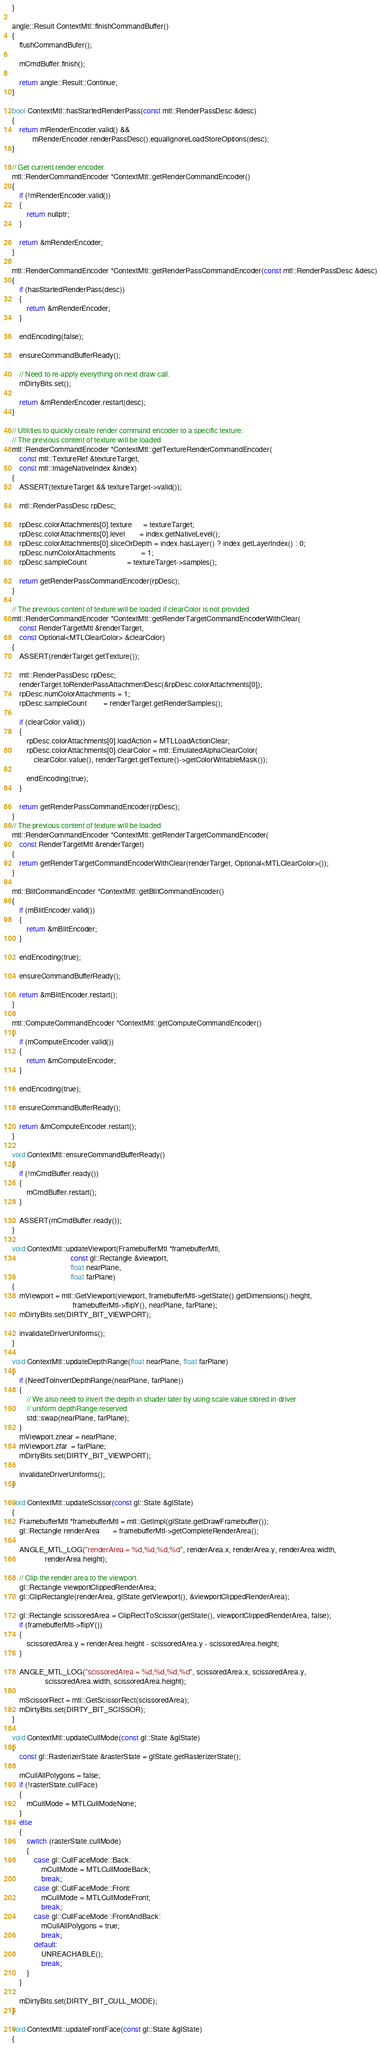<code> <loc_0><loc_0><loc_500><loc_500><_ObjectiveC_>}

angle::Result ContextMtl::finishCommandBuffer()
{
    flushCommandBufer();

    mCmdBuffer.finish();

    return angle::Result::Continue;
}

bool ContextMtl::hasStartedRenderPass(const mtl::RenderPassDesc &desc)
{
    return mRenderEncoder.valid() &&
           mRenderEncoder.renderPassDesc().equalIgnoreLoadStoreOptions(desc);
}

// Get current render encoder
mtl::RenderCommandEncoder *ContextMtl::getRenderCommandEncoder()
{
    if (!mRenderEncoder.valid())
    {
        return nullptr;
    }

    return &mRenderEncoder;
}

mtl::RenderCommandEncoder *ContextMtl::getRenderPassCommandEncoder(const mtl::RenderPassDesc &desc)
{
    if (hasStartedRenderPass(desc))
    {
        return &mRenderEncoder;
    }

    endEncoding(false);

    ensureCommandBufferReady();

    // Need to re-apply everything on next draw call.
    mDirtyBits.set();

    return &mRenderEncoder.restart(desc);
}

// Utilities to quickly create render command encoder to a specific texture:
// The previous content of texture will be loaded
mtl::RenderCommandEncoder *ContextMtl::getTextureRenderCommandEncoder(
    const mtl::TextureRef &textureTarget,
    const mtl::ImageNativeIndex &index)
{
    ASSERT(textureTarget && textureTarget->valid());

    mtl::RenderPassDesc rpDesc;

    rpDesc.colorAttachments[0].texture      = textureTarget;
    rpDesc.colorAttachments[0].level        = index.getNativeLevel();
    rpDesc.colorAttachments[0].sliceOrDepth = index.hasLayer() ? index.getLayerIndex() : 0;
    rpDesc.numColorAttachments              = 1;
    rpDesc.sampleCount                      = textureTarget->samples();

    return getRenderPassCommandEncoder(rpDesc);
}

// The previous content of texture will be loaded if clearColor is not provided
mtl::RenderCommandEncoder *ContextMtl::getRenderTargetCommandEncoderWithClear(
    const RenderTargetMtl &renderTarget,
    const Optional<MTLClearColor> &clearColor)
{
    ASSERT(renderTarget.getTexture());

    mtl::RenderPassDesc rpDesc;
    renderTarget.toRenderPassAttachmentDesc(&rpDesc.colorAttachments[0]);
    rpDesc.numColorAttachments = 1;
    rpDesc.sampleCount         = renderTarget.getRenderSamples();

    if (clearColor.valid())
    {
        rpDesc.colorAttachments[0].loadAction = MTLLoadActionClear;
        rpDesc.colorAttachments[0].clearColor = mtl::EmulatedAlphaClearColor(
            clearColor.value(), renderTarget.getTexture()->getColorWritableMask());

        endEncoding(true);
    }

    return getRenderPassCommandEncoder(rpDesc);
}
// The previous content of texture will be loaded
mtl::RenderCommandEncoder *ContextMtl::getRenderTargetCommandEncoder(
    const RenderTargetMtl &renderTarget)
{
    return getRenderTargetCommandEncoderWithClear(renderTarget, Optional<MTLClearColor>());
}

mtl::BlitCommandEncoder *ContextMtl::getBlitCommandEncoder()
{
    if (mBlitEncoder.valid())
    {
        return &mBlitEncoder;
    }

    endEncoding(true);

    ensureCommandBufferReady();

    return &mBlitEncoder.restart();
}

mtl::ComputeCommandEncoder *ContextMtl::getComputeCommandEncoder()
{
    if (mComputeEncoder.valid())
    {
        return &mComputeEncoder;
    }

    endEncoding(true);

    ensureCommandBufferReady();

    return &mComputeEncoder.restart();
}

void ContextMtl::ensureCommandBufferReady()
{
    if (!mCmdBuffer.ready())
    {
        mCmdBuffer.restart();
    }

    ASSERT(mCmdBuffer.ready());
}

void ContextMtl::updateViewport(FramebufferMtl *framebufferMtl,
                                const gl::Rectangle &viewport,
                                float nearPlane,
                                float farPlane)
{
    mViewport = mtl::GetViewport(viewport, framebufferMtl->getState().getDimensions().height,
                                 framebufferMtl->flipY(), nearPlane, farPlane);
    mDirtyBits.set(DIRTY_BIT_VIEWPORT);

    invalidateDriverUniforms();
}

void ContextMtl::updateDepthRange(float nearPlane, float farPlane)
{
    if (NeedToInvertDepthRange(nearPlane, farPlane))
    {
        // We also need to invert the depth in shader later by using scale value stored in driver
        // uniform depthRange.reserved
        std::swap(nearPlane, farPlane);
    }
    mViewport.znear = nearPlane;
    mViewport.zfar  = farPlane;
    mDirtyBits.set(DIRTY_BIT_VIEWPORT);

    invalidateDriverUniforms();
}

void ContextMtl::updateScissor(const gl::State &glState)
{
    FramebufferMtl *framebufferMtl = mtl::GetImpl(glState.getDrawFramebuffer());
    gl::Rectangle renderArea       = framebufferMtl->getCompleteRenderArea();

    ANGLE_MTL_LOG("renderArea = %d,%d,%d,%d", renderArea.x, renderArea.y, renderArea.width,
                  renderArea.height);

    // Clip the render area to the viewport.
    gl::Rectangle viewportClippedRenderArea;
    gl::ClipRectangle(renderArea, glState.getViewport(), &viewportClippedRenderArea);

    gl::Rectangle scissoredArea = ClipRectToScissor(getState(), viewportClippedRenderArea, false);
    if (framebufferMtl->flipY())
    {
        scissoredArea.y = renderArea.height - scissoredArea.y - scissoredArea.height;
    }

    ANGLE_MTL_LOG("scissoredArea = %d,%d,%d,%d", scissoredArea.x, scissoredArea.y,
                  scissoredArea.width, scissoredArea.height);

    mScissorRect = mtl::GetScissorRect(scissoredArea);
    mDirtyBits.set(DIRTY_BIT_SCISSOR);
}

void ContextMtl::updateCullMode(const gl::State &glState)
{
    const gl::RasterizerState &rasterState = glState.getRasterizerState();

    mCullAllPolygons = false;
    if (!rasterState.cullFace)
    {
        mCullMode = MTLCullModeNone;
    }
    else
    {
        switch (rasterState.cullMode)
        {
            case gl::CullFaceMode::Back:
                mCullMode = MTLCullModeBack;
                break;
            case gl::CullFaceMode::Front:
                mCullMode = MTLCullModeFront;
                break;
            case gl::CullFaceMode::FrontAndBack:
                mCullAllPolygons = true;
                break;
            default:
                UNREACHABLE();
                break;
        }
    }

    mDirtyBits.set(DIRTY_BIT_CULL_MODE);
}

void ContextMtl::updateFrontFace(const gl::State &glState)
{</code> 